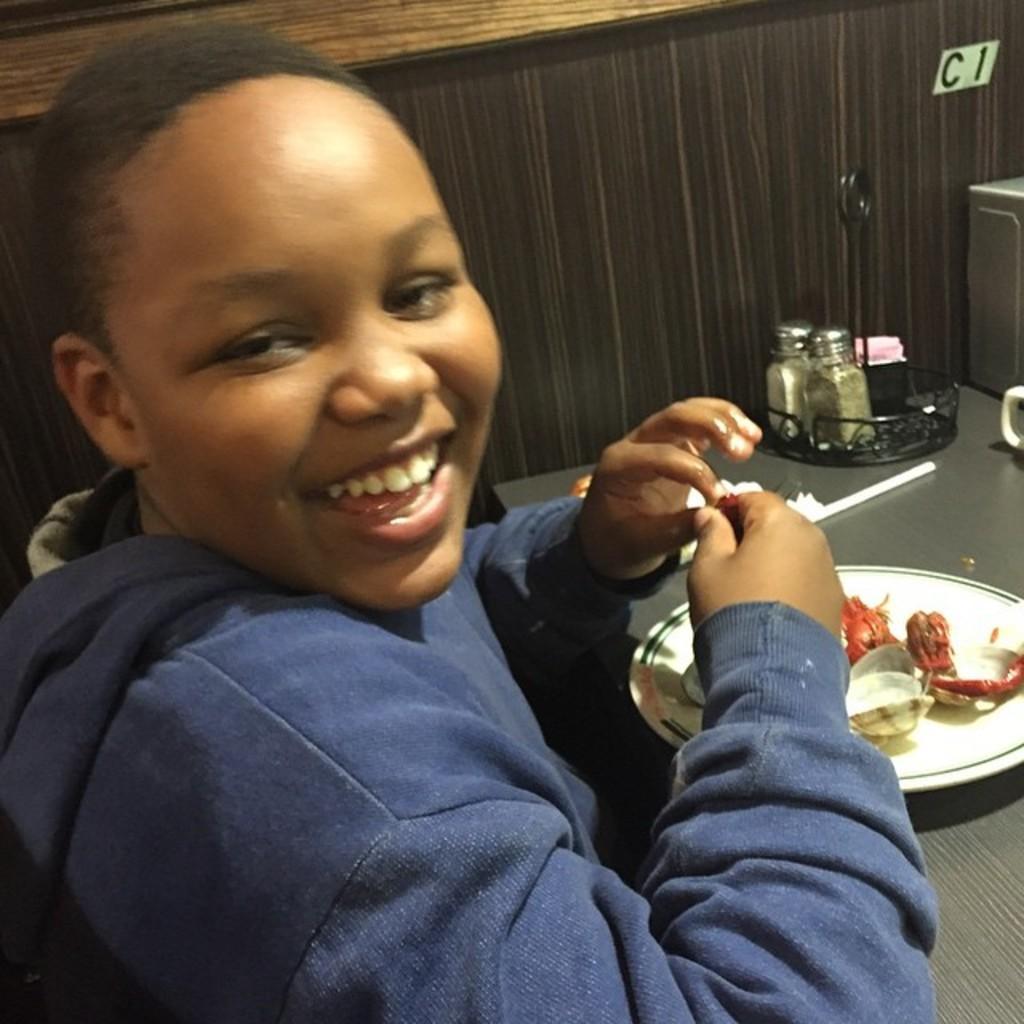Describe this image in one or two sentences. In this picture we can see one boy is sitting on the chair, in front some eatable items are placed on the table. 